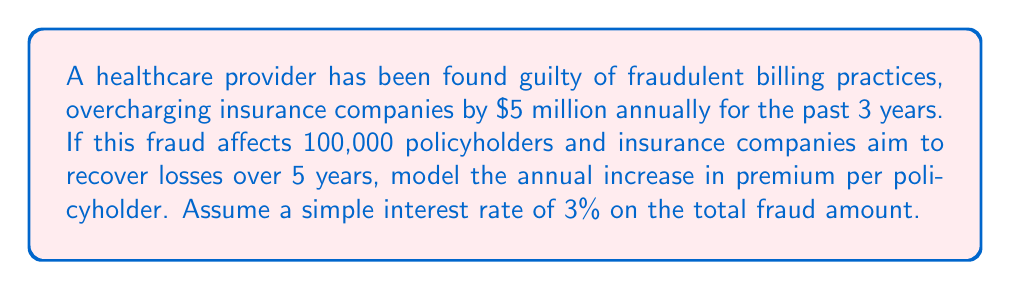What is the answer to this math problem? 1. Calculate the total fraud amount:
   $$\text{Total Fraud} = \$5,000,000 \times 3 \text{ years} = \$15,000,000$$

2. Calculate the interest on the total fraud amount:
   $$\text{Interest} = \$15,000,000 \times 3\% \times 5 \text{ years} = \$2,250,000$$

3. Calculate the total amount to be recovered:
   $$\text{Total Recovery} = \$15,000,000 + \$2,250,000 = \$17,250,000$$

4. Calculate the annual recovery amount:
   $$\text{Annual Recovery} = \frac{\$17,250,000}{5 \text{ years}} = \$3,450,000 \text{ per year}$$

5. Calculate the annual increase in premium per policyholder:
   $$\text{Annual Premium Increase} = \frac{\$3,450,000}{100,000 \text{ policyholders}} = \$34.50 \text{ per policyholder}$$
Answer: $34.50 per policyholder annually 